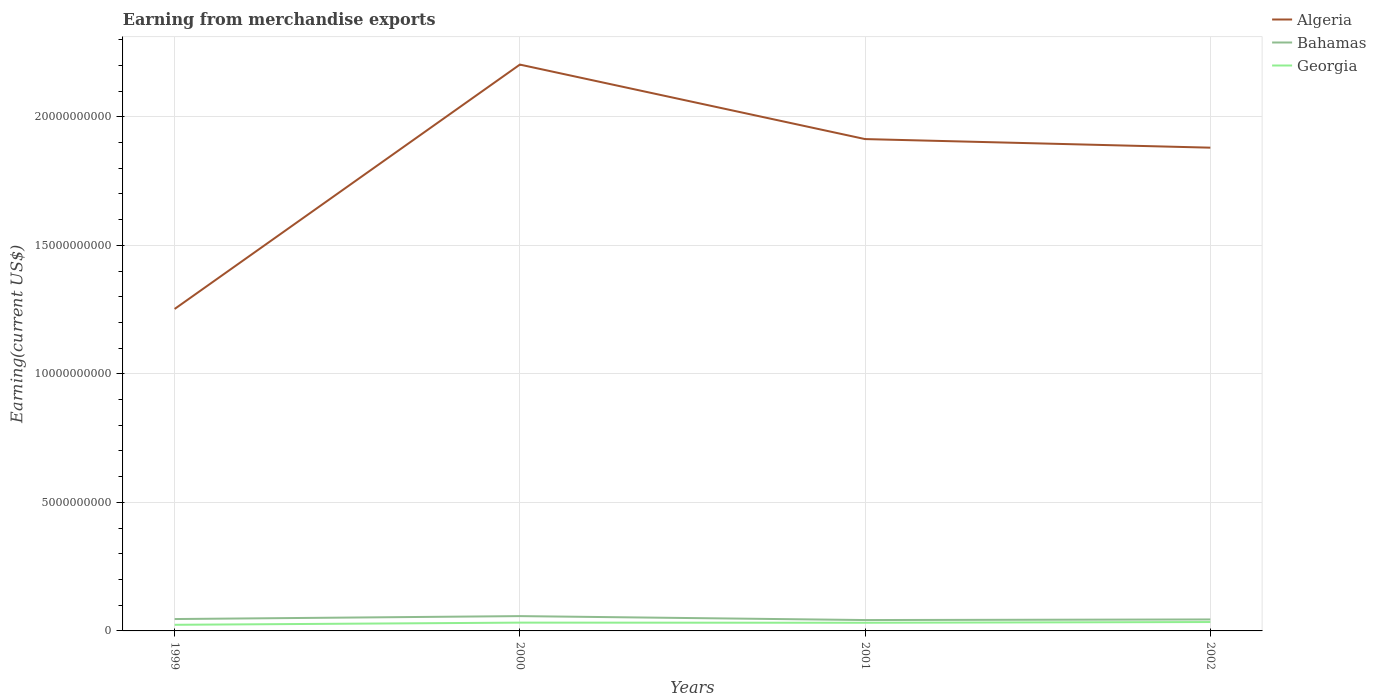How many different coloured lines are there?
Give a very brief answer. 3. Does the line corresponding to Algeria intersect with the line corresponding to Bahamas?
Your answer should be compact. No. Across all years, what is the maximum amount earned from merchandise exports in Georgia?
Make the answer very short. 2.38e+08. What is the total amount earned from merchandise exports in Georgia in the graph?
Give a very brief answer. -8.00e+07. What is the difference between the highest and the second highest amount earned from merchandise exports in Bahamas?
Your answer should be compact. 1.53e+08. Is the amount earned from merchandise exports in Georgia strictly greater than the amount earned from merchandise exports in Bahamas over the years?
Provide a short and direct response. Yes. Does the graph contain any zero values?
Offer a very short reply. No. How are the legend labels stacked?
Your answer should be compact. Vertical. What is the title of the graph?
Keep it short and to the point. Earning from merchandise exports. Does "Paraguay" appear as one of the legend labels in the graph?
Offer a very short reply. No. What is the label or title of the X-axis?
Provide a short and direct response. Years. What is the label or title of the Y-axis?
Make the answer very short. Earning(current US$). What is the Earning(current US$) in Algeria in 1999?
Offer a terse response. 1.25e+1. What is the Earning(current US$) of Bahamas in 1999?
Your answer should be compact. 4.62e+08. What is the Earning(current US$) of Georgia in 1999?
Provide a short and direct response. 2.38e+08. What is the Earning(current US$) of Algeria in 2000?
Offer a very short reply. 2.20e+1. What is the Earning(current US$) in Bahamas in 2000?
Your answer should be very brief. 5.76e+08. What is the Earning(current US$) of Georgia in 2000?
Your response must be concise. 3.23e+08. What is the Earning(current US$) in Algeria in 2001?
Offer a very short reply. 1.91e+1. What is the Earning(current US$) in Bahamas in 2001?
Offer a very short reply. 4.23e+08. What is the Earning(current US$) in Georgia in 2001?
Your answer should be very brief. 3.18e+08. What is the Earning(current US$) in Algeria in 2002?
Provide a succinct answer. 1.88e+1. What is the Earning(current US$) of Bahamas in 2002?
Your answer should be very brief. 4.46e+08. What is the Earning(current US$) of Georgia in 2002?
Make the answer very short. 3.46e+08. Across all years, what is the maximum Earning(current US$) in Algeria?
Give a very brief answer. 2.20e+1. Across all years, what is the maximum Earning(current US$) of Bahamas?
Provide a succinct answer. 5.76e+08. Across all years, what is the maximum Earning(current US$) in Georgia?
Give a very brief answer. 3.46e+08. Across all years, what is the minimum Earning(current US$) in Algeria?
Make the answer very short. 1.25e+1. Across all years, what is the minimum Earning(current US$) in Bahamas?
Your answer should be very brief. 4.23e+08. Across all years, what is the minimum Earning(current US$) of Georgia?
Ensure brevity in your answer.  2.38e+08. What is the total Earning(current US$) of Algeria in the graph?
Your answer should be very brief. 7.25e+1. What is the total Earning(current US$) in Bahamas in the graph?
Provide a succinct answer. 1.91e+09. What is the total Earning(current US$) in Georgia in the graph?
Make the answer very short. 1.22e+09. What is the difference between the Earning(current US$) in Algeria in 1999 and that in 2000?
Your response must be concise. -9.51e+09. What is the difference between the Earning(current US$) of Bahamas in 1999 and that in 2000?
Your answer should be very brief. -1.14e+08. What is the difference between the Earning(current US$) in Georgia in 1999 and that in 2000?
Your response must be concise. -8.50e+07. What is the difference between the Earning(current US$) in Algeria in 1999 and that in 2001?
Ensure brevity in your answer.  -6.61e+09. What is the difference between the Earning(current US$) of Bahamas in 1999 and that in 2001?
Make the answer very short. 3.90e+07. What is the difference between the Earning(current US$) of Georgia in 1999 and that in 2001?
Ensure brevity in your answer.  -8.00e+07. What is the difference between the Earning(current US$) in Algeria in 1999 and that in 2002?
Offer a very short reply. -6.27e+09. What is the difference between the Earning(current US$) in Bahamas in 1999 and that in 2002?
Your answer should be very brief. 1.60e+07. What is the difference between the Earning(current US$) in Georgia in 1999 and that in 2002?
Ensure brevity in your answer.  -1.08e+08. What is the difference between the Earning(current US$) in Algeria in 2000 and that in 2001?
Provide a succinct answer. 2.90e+09. What is the difference between the Earning(current US$) of Bahamas in 2000 and that in 2001?
Ensure brevity in your answer.  1.53e+08. What is the difference between the Earning(current US$) of Algeria in 2000 and that in 2002?
Give a very brief answer. 3.23e+09. What is the difference between the Earning(current US$) of Bahamas in 2000 and that in 2002?
Keep it short and to the point. 1.30e+08. What is the difference between the Earning(current US$) in Georgia in 2000 and that in 2002?
Offer a very short reply. -2.30e+07. What is the difference between the Earning(current US$) of Algeria in 2001 and that in 2002?
Your answer should be very brief. 3.34e+08. What is the difference between the Earning(current US$) in Bahamas in 2001 and that in 2002?
Offer a very short reply. -2.30e+07. What is the difference between the Earning(current US$) of Georgia in 2001 and that in 2002?
Offer a terse response. -2.80e+07. What is the difference between the Earning(current US$) of Algeria in 1999 and the Earning(current US$) of Bahamas in 2000?
Make the answer very short. 1.19e+1. What is the difference between the Earning(current US$) in Algeria in 1999 and the Earning(current US$) in Georgia in 2000?
Your answer should be compact. 1.22e+1. What is the difference between the Earning(current US$) of Bahamas in 1999 and the Earning(current US$) of Georgia in 2000?
Keep it short and to the point. 1.39e+08. What is the difference between the Earning(current US$) of Algeria in 1999 and the Earning(current US$) of Bahamas in 2001?
Ensure brevity in your answer.  1.21e+1. What is the difference between the Earning(current US$) in Algeria in 1999 and the Earning(current US$) in Georgia in 2001?
Your answer should be compact. 1.22e+1. What is the difference between the Earning(current US$) in Bahamas in 1999 and the Earning(current US$) in Georgia in 2001?
Give a very brief answer. 1.44e+08. What is the difference between the Earning(current US$) in Algeria in 1999 and the Earning(current US$) in Bahamas in 2002?
Your answer should be compact. 1.21e+1. What is the difference between the Earning(current US$) of Algeria in 1999 and the Earning(current US$) of Georgia in 2002?
Keep it short and to the point. 1.22e+1. What is the difference between the Earning(current US$) of Bahamas in 1999 and the Earning(current US$) of Georgia in 2002?
Give a very brief answer. 1.16e+08. What is the difference between the Earning(current US$) of Algeria in 2000 and the Earning(current US$) of Bahamas in 2001?
Keep it short and to the point. 2.16e+1. What is the difference between the Earning(current US$) of Algeria in 2000 and the Earning(current US$) of Georgia in 2001?
Provide a succinct answer. 2.17e+1. What is the difference between the Earning(current US$) of Bahamas in 2000 and the Earning(current US$) of Georgia in 2001?
Give a very brief answer. 2.58e+08. What is the difference between the Earning(current US$) in Algeria in 2000 and the Earning(current US$) in Bahamas in 2002?
Keep it short and to the point. 2.16e+1. What is the difference between the Earning(current US$) of Algeria in 2000 and the Earning(current US$) of Georgia in 2002?
Offer a terse response. 2.17e+1. What is the difference between the Earning(current US$) of Bahamas in 2000 and the Earning(current US$) of Georgia in 2002?
Your answer should be compact. 2.30e+08. What is the difference between the Earning(current US$) of Algeria in 2001 and the Earning(current US$) of Bahamas in 2002?
Provide a succinct answer. 1.87e+1. What is the difference between the Earning(current US$) of Algeria in 2001 and the Earning(current US$) of Georgia in 2002?
Your response must be concise. 1.88e+1. What is the difference between the Earning(current US$) of Bahamas in 2001 and the Earning(current US$) of Georgia in 2002?
Your answer should be compact. 7.70e+07. What is the average Earning(current US$) in Algeria per year?
Make the answer very short. 1.81e+1. What is the average Earning(current US$) of Bahamas per year?
Provide a succinct answer. 4.77e+08. What is the average Earning(current US$) in Georgia per year?
Make the answer very short. 3.06e+08. In the year 1999, what is the difference between the Earning(current US$) in Algeria and Earning(current US$) in Bahamas?
Provide a succinct answer. 1.21e+1. In the year 1999, what is the difference between the Earning(current US$) of Algeria and Earning(current US$) of Georgia?
Ensure brevity in your answer.  1.23e+1. In the year 1999, what is the difference between the Earning(current US$) in Bahamas and Earning(current US$) in Georgia?
Ensure brevity in your answer.  2.24e+08. In the year 2000, what is the difference between the Earning(current US$) of Algeria and Earning(current US$) of Bahamas?
Ensure brevity in your answer.  2.15e+1. In the year 2000, what is the difference between the Earning(current US$) in Algeria and Earning(current US$) in Georgia?
Your answer should be very brief. 2.17e+1. In the year 2000, what is the difference between the Earning(current US$) in Bahamas and Earning(current US$) in Georgia?
Your response must be concise. 2.53e+08. In the year 2001, what is the difference between the Earning(current US$) in Algeria and Earning(current US$) in Bahamas?
Provide a succinct answer. 1.87e+1. In the year 2001, what is the difference between the Earning(current US$) in Algeria and Earning(current US$) in Georgia?
Give a very brief answer. 1.88e+1. In the year 2001, what is the difference between the Earning(current US$) of Bahamas and Earning(current US$) of Georgia?
Keep it short and to the point. 1.05e+08. In the year 2002, what is the difference between the Earning(current US$) of Algeria and Earning(current US$) of Bahamas?
Provide a short and direct response. 1.84e+1. In the year 2002, what is the difference between the Earning(current US$) in Algeria and Earning(current US$) in Georgia?
Your answer should be compact. 1.85e+1. In the year 2002, what is the difference between the Earning(current US$) in Bahamas and Earning(current US$) in Georgia?
Offer a terse response. 1.00e+08. What is the ratio of the Earning(current US$) in Algeria in 1999 to that in 2000?
Your answer should be very brief. 0.57. What is the ratio of the Earning(current US$) of Bahamas in 1999 to that in 2000?
Offer a very short reply. 0.8. What is the ratio of the Earning(current US$) in Georgia in 1999 to that in 2000?
Provide a succinct answer. 0.74. What is the ratio of the Earning(current US$) of Algeria in 1999 to that in 2001?
Provide a succinct answer. 0.65. What is the ratio of the Earning(current US$) in Bahamas in 1999 to that in 2001?
Make the answer very short. 1.09. What is the ratio of the Earning(current US$) in Georgia in 1999 to that in 2001?
Make the answer very short. 0.75. What is the ratio of the Earning(current US$) of Algeria in 1999 to that in 2002?
Keep it short and to the point. 0.67. What is the ratio of the Earning(current US$) in Bahamas in 1999 to that in 2002?
Ensure brevity in your answer.  1.04. What is the ratio of the Earning(current US$) of Georgia in 1999 to that in 2002?
Offer a terse response. 0.69. What is the ratio of the Earning(current US$) in Algeria in 2000 to that in 2001?
Give a very brief answer. 1.15. What is the ratio of the Earning(current US$) of Bahamas in 2000 to that in 2001?
Your response must be concise. 1.36. What is the ratio of the Earning(current US$) in Georgia in 2000 to that in 2001?
Keep it short and to the point. 1.02. What is the ratio of the Earning(current US$) of Algeria in 2000 to that in 2002?
Provide a short and direct response. 1.17. What is the ratio of the Earning(current US$) of Bahamas in 2000 to that in 2002?
Your answer should be very brief. 1.29. What is the ratio of the Earning(current US$) in Georgia in 2000 to that in 2002?
Give a very brief answer. 0.93. What is the ratio of the Earning(current US$) of Algeria in 2001 to that in 2002?
Make the answer very short. 1.02. What is the ratio of the Earning(current US$) of Bahamas in 2001 to that in 2002?
Keep it short and to the point. 0.95. What is the ratio of the Earning(current US$) of Georgia in 2001 to that in 2002?
Your response must be concise. 0.92. What is the difference between the highest and the second highest Earning(current US$) of Algeria?
Your answer should be very brief. 2.90e+09. What is the difference between the highest and the second highest Earning(current US$) in Bahamas?
Offer a very short reply. 1.14e+08. What is the difference between the highest and the second highest Earning(current US$) of Georgia?
Make the answer very short. 2.30e+07. What is the difference between the highest and the lowest Earning(current US$) in Algeria?
Make the answer very short. 9.51e+09. What is the difference between the highest and the lowest Earning(current US$) in Bahamas?
Provide a succinct answer. 1.53e+08. What is the difference between the highest and the lowest Earning(current US$) of Georgia?
Offer a very short reply. 1.08e+08. 